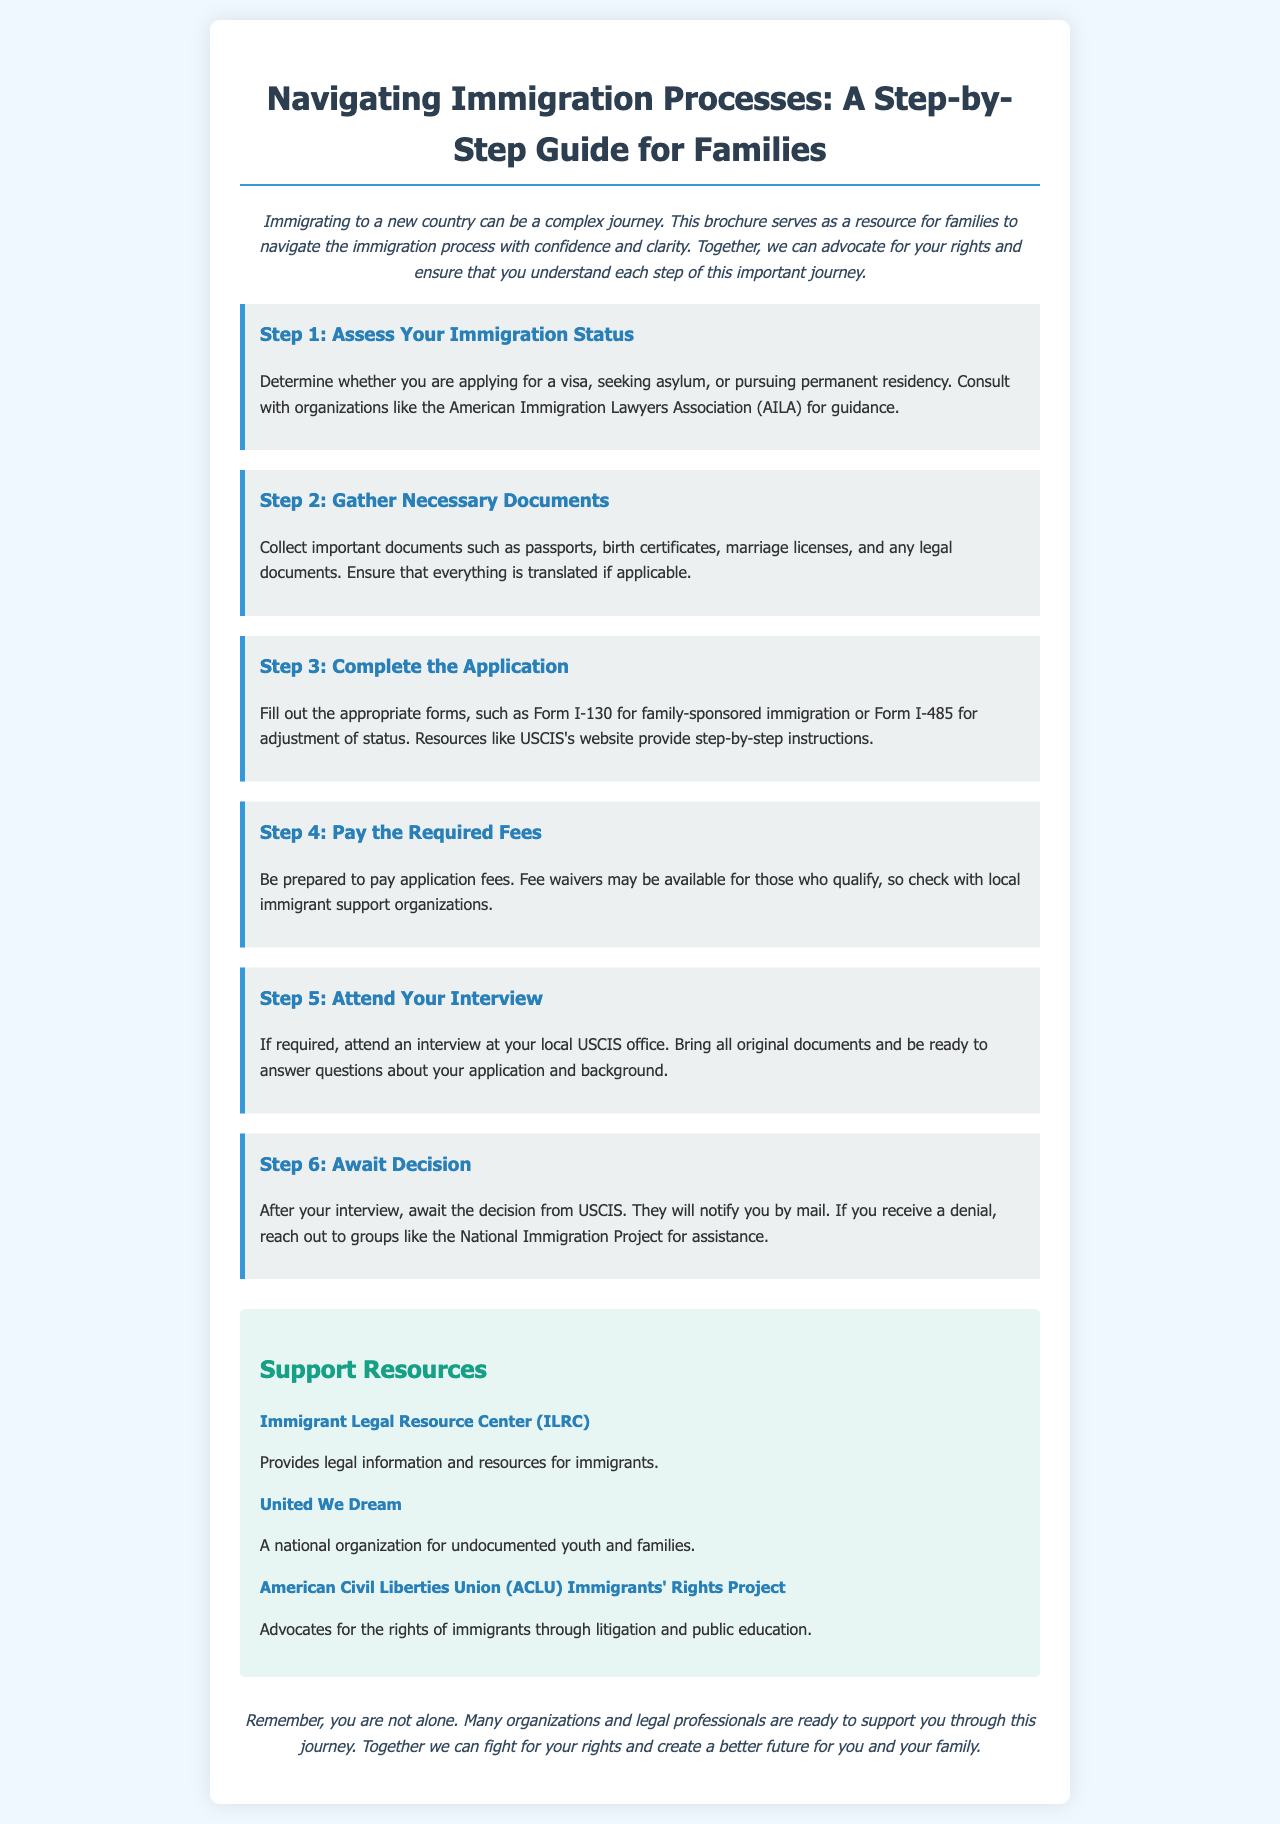What is the title of the brochure? The title of the brochure is prominently displayed at the top, reading "Navigating Immigration Processes: A Step-by-Step Guide for Families."
Answer: Navigating Immigration Processes: A Step-by-Step Guide for Families How many steps are outlined in the immigration process? The document lists a total of six steps for families to follow in the immigration process.
Answer: 6 What is the first step in the immigration process? The first step mentioned in the document is "Assess Your Immigration Status."
Answer: Assess Your Immigration Status What organization is suggested for guidance in the first step? The brochure suggests consulting with the American Immigration Lawyers Association (AILA) for guidance in the first step.
Answer: American Immigration Lawyers Association (AILA) Which step includes attending an interview? The fifth step specifically mentions attending an interview at the local USCIS office as part of the immigration process.
Answer: Step 5 What type of documents should be gathered in Step 2? Step 2 advises gathering important documents such as passports, birth certificates, and marriage licenses.
Answer: Passports, birth certificates, marriage licenses Which organization focuses on undocumented youth and families? United We Dream is the organization highlighted in the resources that focuses on undocumented youth and families.
Answer: United We Dream What is the color of the background in the brochure? The background color of the brochure is a light blue, specified in the CSS as hex code #f0f8ff.
Answer: Light blue What does the brochure emphasize in the closing statement? The brochure emphasizes the support available from organizations and legal professionals in the closing statement.
Answer: Support available from organizations and legal professionals 